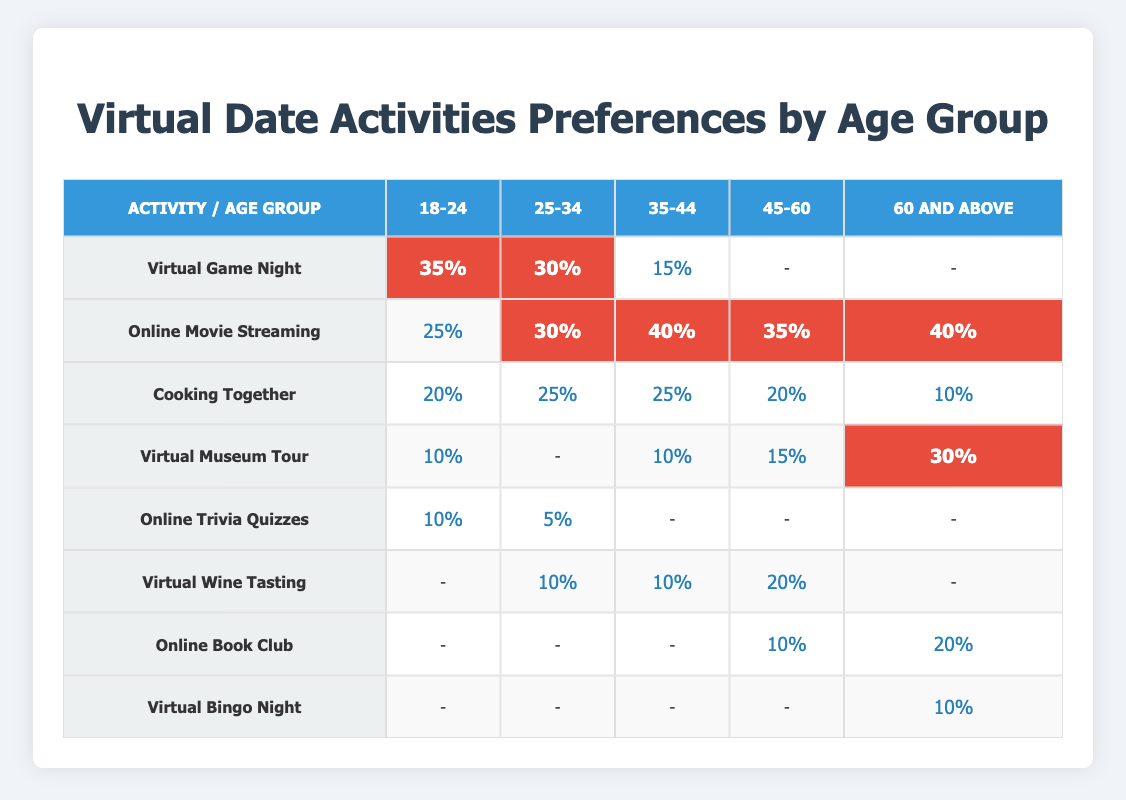What is the most preferred activity for the age group 35-44? The highest value in the 35-44 age group can be found in the "Online Movie Streaming" row, which has 40% participation.
Answer: Online Movie Streaming Which age group shows the least interest in Cooking Together? For the "Cooking Together" activity, the age group 60 and above shows the lowest percentage, with only 10%.
Answer: 60 and above Is Virtual Wine Tasting more preferred than Cooking Together among couples aged 45-60? In the 45-60 age group, "Virtual Wine Tasting" has 20%, while "Cooking Together" has 20% as well, so they are equal.
Answer: No What is the total percentage of preferences for Online Movie Streaming across all age groups? Adding the percentages for "Online Movie Streaming" gives: 25 + 30 + 40 + 35 + 40 = 170%.
Answer: 170% Which activity has no preference among the 18-24 age group? The activities that show a preference of "-" (no interest) in the 18-24 age group are "Virtual Wine Tasting," "Online Book Club," and "Virtual Bingo Night."
Answer: Virtual Wine Tasting, Online Book Club, Virtual Bingo Night How does the preference for Virtual Game Night compare between the age groups 18-24 and 25-34? The preference for "Virtual Game Night" is 35% in the 18-24 age group and 30% in the 25-34 age group, which means 18-24 prefers it more.
Answer: 18-24 prefers it more What is the average percentage of preference for Virtual Museum Tour across all age groups? Adding the percentages for "Virtual Museum Tour": 10 + 0 + 10 + 15 + 30 = 65. To find the average, divide by 5 (the number of age groups): 65/5 = 13%.
Answer: 13% Is there a significant difference in preference for Online Trivia Quizzes across the different age groups? The percentages for "Online Trivia Quizzes" are: 10% (18-24), 5% (25-34), 0% (35-44), 0% (45-60), and 0% (60 and above). The only significant value is in 18-24.
Answer: Yes, only significant in 18-24 